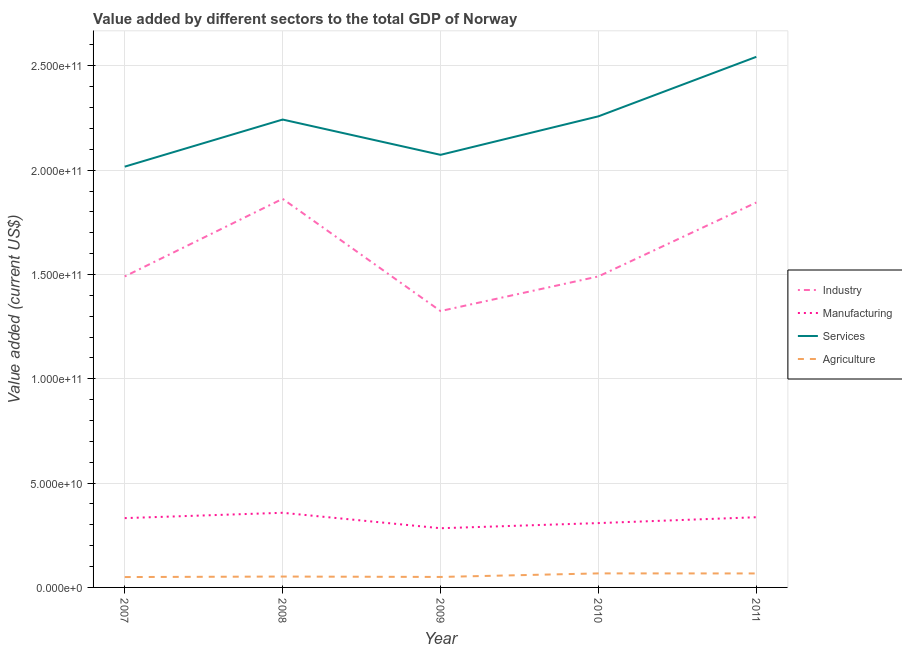How many different coloured lines are there?
Provide a short and direct response. 4. Is the number of lines equal to the number of legend labels?
Provide a succinct answer. Yes. What is the value added by industrial sector in 2010?
Keep it short and to the point. 1.49e+11. Across all years, what is the maximum value added by manufacturing sector?
Your response must be concise. 3.58e+1. Across all years, what is the minimum value added by services sector?
Your response must be concise. 2.02e+11. What is the total value added by services sector in the graph?
Provide a succinct answer. 1.11e+12. What is the difference between the value added by manufacturing sector in 2008 and that in 2011?
Give a very brief answer. 2.13e+09. What is the difference between the value added by industrial sector in 2009 and the value added by agricultural sector in 2008?
Ensure brevity in your answer.  1.27e+11. What is the average value added by agricultural sector per year?
Offer a terse response. 5.73e+09. In the year 2010, what is the difference between the value added by services sector and value added by agricultural sector?
Give a very brief answer. 2.19e+11. What is the ratio of the value added by services sector in 2007 to that in 2009?
Make the answer very short. 0.97. What is the difference between the highest and the second highest value added by agricultural sector?
Your response must be concise. 2.52e+07. What is the difference between the highest and the lowest value added by manufacturing sector?
Offer a terse response. 7.41e+09. In how many years, is the value added by manufacturing sector greater than the average value added by manufacturing sector taken over all years?
Offer a terse response. 3. Is the value added by manufacturing sector strictly less than the value added by agricultural sector over the years?
Offer a terse response. No. How many lines are there?
Give a very brief answer. 4. Does the graph contain grids?
Ensure brevity in your answer.  Yes. How are the legend labels stacked?
Provide a short and direct response. Vertical. What is the title of the graph?
Keep it short and to the point. Value added by different sectors to the total GDP of Norway. Does "Korea" appear as one of the legend labels in the graph?
Your answer should be compact. No. What is the label or title of the X-axis?
Make the answer very short. Year. What is the label or title of the Y-axis?
Offer a terse response. Value added (current US$). What is the Value added (current US$) of Industry in 2007?
Ensure brevity in your answer.  1.49e+11. What is the Value added (current US$) in Manufacturing in 2007?
Your answer should be compact. 3.32e+1. What is the Value added (current US$) in Services in 2007?
Ensure brevity in your answer.  2.02e+11. What is the Value added (current US$) in Agriculture in 2007?
Offer a very short reply. 4.97e+09. What is the Value added (current US$) of Industry in 2008?
Your response must be concise. 1.86e+11. What is the Value added (current US$) in Manufacturing in 2008?
Provide a succinct answer. 3.58e+1. What is the Value added (current US$) in Services in 2008?
Provide a short and direct response. 2.24e+11. What is the Value added (current US$) of Agriculture in 2008?
Give a very brief answer. 5.21e+09. What is the Value added (current US$) of Industry in 2009?
Ensure brevity in your answer.  1.32e+11. What is the Value added (current US$) in Manufacturing in 2009?
Your response must be concise. 2.84e+1. What is the Value added (current US$) of Services in 2009?
Provide a succinct answer. 2.07e+11. What is the Value added (current US$) of Agriculture in 2009?
Keep it short and to the point. 5.02e+09. What is the Value added (current US$) of Industry in 2010?
Provide a short and direct response. 1.49e+11. What is the Value added (current US$) of Manufacturing in 2010?
Ensure brevity in your answer.  3.08e+1. What is the Value added (current US$) of Services in 2010?
Give a very brief answer. 2.26e+11. What is the Value added (current US$) of Agriculture in 2010?
Keep it short and to the point. 6.73e+09. What is the Value added (current US$) of Industry in 2011?
Provide a succinct answer. 1.84e+11. What is the Value added (current US$) in Manufacturing in 2011?
Provide a short and direct response. 3.36e+1. What is the Value added (current US$) in Services in 2011?
Ensure brevity in your answer.  2.54e+11. What is the Value added (current US$) of Agriculture in 2011?
Your answer should be compact. 6.70e+09. Across all years, what is the maximum Value added (current US$) in Industry?
Give a very brief answer. 1.86e+11. Across all years, what is the maximum Value added (current US$) of Manufacturing?
Your response must be concise. 3.58e+1. Across all years, what is the maximum Value added (current US$) of Services?
Your answer should be very brief. 2.54e+11. Across all years, what is the maximum Value added (current US$) in Agriculture?
Make the answer very short. 6.73e+09. Across all years, what is the minimum Value added (current US$) of Industry?
Provide a succinct answer. 1.32e+11. Across all years, what is the minimum Value added (current US$) in Manufacturing?
Your response must be concise. 2.84e+1. Across all years, what is the minimum Value added (current US$) of Services?
Ensure brevity in your answer.  2.02e+11. Across all years, what is the minimum Value added (current US$) in Agriculture?
Give a very brief answer. 4.97e+09. What is the total Value added (current US$) in Industry in the graph?
Provide a succinct answer. 8.01e+11. What is the total Value added (current US$) of Manufacturing in the graph?
Offer a very short reply. 1.62e+11. What is the total Value added (current US$) of Services in the graph?
Provide a short and direct response. 1.11e+12. What is the total Value added (current US$) of Agriculture in the graph?
Offer a very short reply. 2.86e+1. What is the difference between the Value added (current US$) in Industry in 2007 and that in 2008?
Offer a terse response. -3.72e+1. What is the difference between the Value added (current US$) of Manufacturing in 2007 and that in 2008?
Ensure brevity in your answer.  -2.56e+09. What is the difference between the Value added (current US$) of Services in 2007 and that in 2008?
Give a very brief answer. -2.26e+1. What is the difference between the Value added (current US$) in Agriculture in 2007 and that in 2008?
Provide a succinct answer. -2.43e+08. What is the difference between the Value added (current US$) in Industry in 2007 and that in 2009?
Keep it short and to the point. 1.66e+1. What is the difference between the Value added (current US$) in Manufacturing in 2007 and that in 2009?
Your response must be concise. 4.85e+09. What is the difference between the Value added (current US$) in Services in 2007 and that in 2009?
Ensure brevity in your answer.  -5.67e+09. What is the difference between the Value added (current US$) in Agriculture in 2007 and that in 2009?
Make the answer very short. -5.06e+07. What is the difference between the Value added (current US$) in Industry in 2007 and that in 2010?
Your answer should be very brief. -1.07e+07. What is the difference between the Value added (current US$) of Manufacturing in 2007 and that in 2010?
Provide a succinct answer. 2.39e+09. What is the difference between the Value added (current US$) of Services in 2007 and that in 2010?
Your answer should be very brief. -2.41e+1. What is the difference between the Value added (current US$) of Agriculture in 2007 and that in 2010?
Provide a short and direct response. -1.75e+09. What is the difference between the Value added (current US$) in Industry in 2007 and that in 2011?
Provide a short and direct response. -3.54e+1. What is the difference between the Value added (current US$) in Manufacturing in 2007 and that in 2011?
Provide a succinct answer. -4.24e+08. What is the difference between the Value added (current US$) of Services in 2007 and that in 2011?
Keep it short and to the point. -5.26e+1. What is the difference between the Value added (current US$) in Agriculture in 2007 and that in 2011?
Offer a terse response. -1.73e+09. What is the difference between the Value added (current US$) of Industry in 2008 and that in 2009?
Make the answer very short. 5.38e+1. What is the difference between the Value added (current US$) of Manufacturing in 2008 and that in 2009?
Ensure brevity in your answer.  7.41e+09. What is the difference between the Value added (current US$) in Services in 2008 and that in 2009?
Ensure brevity in your answer.  1.69e+1. What is the difference between the Value added (current US$) of Agriculture in 2008 and that in 2009?
Your response must be concise. 1.92e+08. What is the difference between the Value added (current US$) of Industry in 2008 and that in 2010?
Make the answer very short. 3.72e+1. What is the difference between the Value added (current US$) in Manufacturing in 2008 and that in 2010?
Provide a short and direct response. 4.94e+09. What is the difference between the Value added (current US$) of Services in 2008 and that in 2010?
Give a very brief answer. -1.54e+09. What is the difference between the Value added (current US$) of Agriculture in 2008 and that in 2010?
Ensure brevity in your answer.  -1.51e+09. What is the difference between the Value added (current US$) in Industry in 2008 and that in 2011?
Keep it short and to the point. 1.77e+09. What is the difference between the Value added (current US$) of Manufacturing in 2008 and that in 2011?
Provide a short and direct response. 2.13e+09. What is the difference between the Value added (current US$) in Services in 2008 and that in 2011?
Your answer should be very brief. -3.01e+1. What is the difference between the Value added (current US$) in Agriculture in 2008 and that in 2011?
Your answer should be compact. -1.49e+09. What is the difference between the Value added (current US$) in Industry in 2009 and that in 2010?
Ensure brevity in your answer.  -1.66e+1. What is the difference between the Value added (current US$) in Manufacturing in 2009 and that in 2010?
Offer a terse response. -2.46e+09. What is the difference between the Value added (current US$) of Services in 2009 and that in 2010?
Make the answer very short. -1.85e+1. What is the difference between the Value added (current US$) of Agriculture in 2009 and that in 2010?
Offer a very short reply. -1.70e+09. What is the difference between the Value added (current US$) of Industry in 2009 and that in 2011?
Provide a succinct answer. -5.20e+1. What is the difference between the Value added (current US$) of Manufacturing in 2009 and that in 2011?
Offer a very short reply. -5.28e+09. What is the difference between the Value added (current US$) of Services in 2009 and that in 2011?
Provide a short and direct response. -4.70e+1. What is the difference between the Value added (current US$) in Agriculture in 2009 and that in 2011?
Keep it short and to the point. -1.68e+09. What is the difference between the Value added (current US$) in Industry in 2010 and that in 2011?
Offer a terse response. -3.54e+1. What is the difference between the Value added (current US$) in Manufacturing in 2010 and that in 2011?
Give a very brief answer. -2.81e+09. What is the difference between the Value added (current US$) in Services in 2010 and that in 2011?
Your response must be concise. -2.85e+1. What is the difference between the Value added (current US$) in Agriculture in 2010 and that in 2011?
Keep it short and to the point. 2.52e+07. What is the difference between the Value added (current US$) of Industry in 2007 and the Value added (current US$) of Manufacturing in 2008?
Provide a succinct answer. 1.13e+11. What is the difference between the Value added (current US$) of Industry in 2007 and the Value added (current US$) of Services in 2008?
Keep it short and to the point. -7.52e+1. What is the difference between the Value added (current US$) in Industry in 2007 and the Value added (current US$) in Agriculture in 2008?
Offer a terse response. 1.44e+11. What is the difference between the Value added (current US$) of Manufacturing in 2007 and the Value added (current US$) of Services in 2008?
Provide a succinct answer. -1.91e+11. What is the difference between the Value added (current US$) of Manufacturing in 2007 and the Value added (current US$) of Agriculture in 2008?
Your response must be concise. 2.80e+1. What is the difference between the Value added (current US$) in Services in 2007 and the Value added (current US$) in Agriculture in 2008?
Ensure brevity in your answer.  1.96e+11. What is the difference between the Value added (current US$) of Industry in 2007 and the Value added (current US$) of Manufacturing in 2009?
Offer a terse response. 1.21e+11. What is the difference between the Value added (current US$) of Industry in 2007 and the Value added (current US$) of Services in 2009?
Offer a very short reply. -5.83e+1. What is the difference between the Value added (current US$) of Industry in 2007 and the Value added (current US$) of Agriculture in 2009?
Your answer should be very brief. 1.44e+11. What is the difference between the Value added (current US$) of Manufacturing in 2007 and the Value added (current US$) of Services in 2009?
Make the answer very short. -1.74e+11. What is the difference between the Value added (current US$) in Manufacturing in 2007 and the Value added (current US$) in Agriculture in 2009?
Provide a succinct answer. 2.82e+1. What is the difference between the Value added (current US$) in Services in 2007 and the Value added (current US$) in Agriculture in 2009?
Keep it short and to the point. 1.97e+11. What is the difference between the Value added (current US$) of Industry in 2007 and the Value added (current US$) of Manufacturing in 2010?
Keep it short and to the point. 1.18e+11. What is the difference between the Value added (current US$) in Industry in 2007 and the Value added (current US$) in Services in 2010?
Offer a terse response. -7.67e+1. What is the difference between the Value added (current US$) in Industry in 2007 and the Value added (current US$) in Agriculture in 2010?
Give a very brief answer. 1.42e+11. What is the difference between the Value added (current US$) of Manufacturing in 2007 and the Value added (current US$) of Services in 2010?
Your answer should be very brief. -1.93e+11. What is the difference between the Value added (current US$) in Manufacturing in 2007 and the Value added (current US$) in Agriculture in 2010?
Offer a very short reply. 2.65e+1. What is the difference between the Value added (current US$) in Services in 2007 and the Value added (current US$) in Agriculture in 2010?
Provide a short and direct response. 1.95e+11. What is the difference between the Value added (current US$) of Industry in 2007 and the Value added (current US$) of Manufacturing in 2011?
Your answer should be very brief. 1.15e+11. What is the difference between the Value added (current US$) in Industry in 2007 and the Value added (current US$) in Services in 2011?
Ensure brevity in your answer.  -1.05e+11. What is the difference between the Value added (current US$) of Industry in 2007 and the Value added (current US$) of Agriculture in 2011?
Your answer should be compact. 1.42e+11. What is the difference between the Value added (current US$) of Manufacturing in 2007 and the Value added (current US$) of Services in 2011?
Make the answer very short. -2.21e+11. What is the difference between the Value added (current US$) in Manufacturing in 2007 and the Value added (current US$) in Agriculture in 2011?
Offer a very short reply. 2.65e+1. What is the difference between the Value added (current US$) of Services in 2007 and the Value added (current US$) of Agriculture in 2011?
Make the answer very short. 1.95e+11. What is the difference between the Value added (current US$) in Industry in 2008 and the Value added (current US$) in Manufacturing in 2009?
Make the answer very short. 1.58e+11. What is the difference between the Value added (current US$) in Industry in 2008 and the Value added (current US$) in Services in 2009?
Your answer should be very brief. -2.11e+1. What is the difference between the Value added (current US$) in Industry in 2008 and the Value added (current US$) in Agriculture in 2009?
Your answer should be compact. 1.81e+11. What is the difference between the Value added (current US$) of Manufacturing in 2008 and the Value added (current US$) of Services in 2009?
Your answer should be compact. -1.72e+11. What is the difference between the Value added (current US$) of Manufacturing in 2008 and the Value added (current US$) of Agriculture in 2009?
Your answer should be very brief. 3.08e+1. What is the difference between the Value added (current US$) of Services in 2008 and the Value added (current US$) of Agriculture in 2009?
Make the answer very short. 2.19e+11. What is the difference between the Value added (current US$) of Industry in 2008 and the Value added (current US$) of Manufacturing in 2010?
Keep it short and to the point. 1.55e+11. What is the difference between the Value added (current US$) of Industry in 2008 and the Value added (current US$) of Services in 2010?
Keep it short and to the point. -3.95e+1. What is the difference between the Value added (current US$) of Industry in 2008 and the Value added (current US$) of Agriculture in 2010?
Offer a very short reply. 1.80e+11. What is the difference between the Value added (current US$) in Manufacturing in 2008 and the Value added (current US$) in Services in 2010?
Keep it short and to the point. -1.90e+11. What is the difference between the Value added (current US$) in Manufacturing in 2008 and the Value added (current US$) in Agriculture in 2010?
Offer a terse response. 2.91e+1. What is the difference between the Value added (current US$) of Services in 2008 and the Value added (current US$) of Agriculture in 2010?
Give a very brief answer. 2.18e+11. What is the difference between the Value added (current US$) in Industry in 2008 and the Value added (current US$) in Manufacturing in 2011?
Offer a very short reply. 1.53e+11. What is the difference between the Value added (current US$) in Industry in 2008 and the Value added (current US$) in Services in 2011?
Make the answer very short. -6.81e+1. What is the difference between the Value added (current US$) in Industry in 2008 and the Value added (current US$) in Agriculture in 2011?
Offer a very short reply. 1.80e+11. What is the difference between the Value added (current US$) in Manufacturing in 2008 and the Value added (current US$) in Services in 2011?
Your response must be concise. -2.19e+11. What is the difference between the Value added (current US$) in Manufacturing in 2008 and the Value added (current US$) in Agriculture in 2011?
Your answer should be compact. 2.91e+1. What is the difference between the Value added (current US$) in Services in 2008 and the Value added (current US$) in Agriculture in 2011?
Offer a terse response. 2.18e+11. What is the difference between the Value added (current US$) in Industry in 2009 and the Value added (current US$) in Manufacturing in 2010?
Keep it short and to the point. 1.02e+11. What is the difference between the Value added (current US$) of Industry in 2009 and the Value added (current US$) of Services in 2010?
Your answer should be compact. -9.33e+1. What is the difference between the Value added (current US$) in Industry in 2009 and the Value added (current US$) in Agriculture in 2010?
Your answer should be very brief. 1.26e+11. What is the difference between the Value added (current US$) in Manufacturing in 2009 and the Value added (current US$) in Services in 2010?
Offer a terse response. -1.97e+11. What is the difference between the Value added (current US$) in Manufacturing in 2009 and the Value added (current US$) in Agriculture in 2010?
Ensure brevity in your answer.  2.16e+1. What is the difference between the Value added (current US$) of Services in 2009 and the Value added (current US$) of Agriculture in 2010?
Provide a succinct answer. 2.01e+11. What is the difference between the Value added (current US$) of Industry in 2009 and the Value added (current US$) of Manufacturing in 2011?
Provide a short and direct response. 9.88e+1. What is the difference between the Value added (current US$) of Industry in 2009 and the Value added (current US$) of Services in 2011?
Make the answer very short. -1.22e+11. What is the difference between the Value added (current US$) in Industry in 2009 and the Value added (current US$) in Agriculture in 2011?
Your answer should be very brief. 1.26e+11. What is the difference between the Value added (current US$) of Manufacturing in 2009 and the Value added (current US$) of Services in 2011?
Your answer should be compact. -2.26e+11. What is the difference between the Value added (current US$) in Manufacturing in 2009 and the Value added (current US$) in Agriculture in 2011?
Give a very brief answer. 2.17e+1. What is the difference between the Value added (current US$) in Services in 2009 and the Value added (current US$) in Agriculture in 2011?
Ensure brevity in your answer.  2.01e+11. What is the difference between the Value added (current US$) in Industry in 2010 and the Value added (current US$) in Manufacturing in 2011?
Ensure brevity in your answer.  1.15e+11. What is the difference between the Value added (current US$) of Industry in 2010 and the Value added (current US$) of Services in 2011?
Your response must be concise. -1.05e+11. What is the difference between the Value added (current US$) in Industry in 2010 and the Value added (current US$) in Agriculture in 2011?
Provide a succinct answer. 1.42e+11. What is the difference between the Value added (current US$) of Manufacturing in 2010 and the Value added (current US$) of Services in 2011?
Provide a short and direct response. -2.23e+11. What is the difference between the Value added (current US$) of Manufacturing in 2010 and the Value added (current US$) of Agriculture in 2011?
Ensure brevity in your answer.  2.41e+1. What is the difference between the Value added (current US$) of Services in 2010 and the Value added (current US$) of Agriculture in 2011?
Give a very brief answer. 2.19e+11. What is the average Value added (current US$) in Industry per year?
Give a very brief answer. 1.60e+11. What is the average Value added (current US$) of Manufacturing per year?
Give a very brief answer. 3.24e+1. What is the average Value added (current US$) in Services per year?
Your answer should be compact. 2.23e+11. What is the average Value added (current US$) of Agriculture per year?
Your response must be concise. 5.73e+09. In the year 2007, what is the difference between the Value added (current US$) of Industry and Value added (current US$) of Manufacturing?
Ensure brevity in your answer.  1.16e+11. In the year 2007, what is the difference between the Value added (current US$) of Industry and Value added (current US$) of Services?
Give a very brief answer. -5.26e+1. In the year 2007, what is the difference between the Value added (current US$) in Industry and Value added (current US$) in Agriculture?
Provide a short and direct response. 1.44e+11. In the year 2007, what is the difference between the Value added (current US$) in Manufacturing and Value added (current US$) in Services?
Provide a succinct answer. -1.68e+11. In the year 2007, what is the difference between the Value added (current US$) of Manufacturing and Value added (current US$) of Agriculture?
Your answer should be compact. 2.83e+1. In the year 2007, what is the difference between the Value added (current US$) in Services and Value added (current US$) in Agriculture?
Give a very brief answer. 1.97e+11. In the year 2008, what is the difference between the Value added (current US$) in Industry and Value added (current US$) in Manufacturing?
Make the answer very short. 1.50e+11. In the year 2008, what is the difference between the Value added (current US$) of Industry and Value added (current US$) of Services?
Offer a very short reply. -3.80e+1. In the year 2008, what is the difference between the Value added (current US$) of Industry and Value added (current US$) of Agriculture?
Give a very brief answer. 1.81e+11. In the year 2008, what is the difference between the Value added (current US$) of Manufacturing and Value added (current US$) of Services?
Your answer should be compact. -1.88e+11. In the year 2008, what is the difference between the Value added (current US$) of Manufacturing and Value added (current US$) of Agriculture?
Keep it short and to the point. 3.06e+1. In the year 2008, what is the difference between the Value added (current US$) of Services and Value added (current US$) of Agriculture?
Your answer should be very brief. 2.19e+11. In the year 2009, what is the difference between the Value added (current US$) in Industry and Value added (current US$) in Manufacturing?
Provide a short and direct response. 1.04e+11. In the year 2009, what is the difference between the Value added (current US$) in Industry and Value added (current US$) in Services?
Your answer should be very brief. -7.49e+1. In the year 2009, what is the difference between the Value added (current US$) in Industry and Value added (current US$) in Agriculture?
Ensure brevity in your answer.  1.27e+11. In the year 2009, what is the difference between the Value added (current US$) in Manufacturing and Value added (current US$) in Services?
Your response must be concise. -1.79e+11. In the year 2009, what is the difference between the Value added (current US$) in Manufacturing and Value added (current US$) in Agriculture?
Ensure brevity in your answer.  2.34e+1. In the year 2009, what is the difference between the Value added (current US$) of Services and Value added (current US$) of Agriculture?
Make the answer very short. 2.02e+11. In the year 2010, what is the difference between the Value added (current US$) of Industry and Value added (current US$) of Manufacturing?
Keep it short and to the point. 1.18e+11. In the year 2010, what is the difference between the Value added (current US$) of Industry and Value added (current US$) of Services?
Provide a succinct answer. -7.67e+1. In the year 2010, what is the difference between the Value added (current US$) of Industry and Value added (current US$) of Agriculture?
Make the answer very short. 1.42e+11. In the year 2010, what is the difference between the Value added (current US$) of Manufacturing and Value added (current US$) of Services?
Provide a succinct answer. -1.95e+11. In the year 2010, what is the difference between the Value added (current US$) of Manufacturing and Value added (current US$) of Agriculture?
Ensure brevity in your answer.  2.41e+1. In the year 2010, what is the difference between the Value added (current US$) of Services and Value added (current US$) of Agriculture?
Offer a very short reply. 2.19e+11. In the year 2011, what is the difference between the Value added (current US$) in Industry and Value added (current US$) in Manufacturing?
Offer a very short reply. 1.51e+11. In the year 2011, what is the difference between the Value added (current US$) in Industry and Value added (current US$) in Services?
Give a very brief answer. -6.98e+1. In the year 2011, what is the difference between the Value added (current US$) of Industry and Value added (current US$) of Agriculture?
Provide a succinct answer. 1.78e+11. In the year 2011, what is the difference between the Value added (current US$) of Manufacturing and Value added (current US$) of Services?
Make the answer very short. -2.21e+11. In the year 2011, what is the difference between the Value added (current US$) in Manufacturing and Value added (current US$) in Agriculture?
Provide a succinct answer. 2.69e+1. In the year 2011, what is the difference between the Value added (current US$) of Services and Value added (current US$) of Agriculture?
Provide a short and direct response. 2.48e+11. What is the ratio of the Value added (current US$) of Industry in 2007 to that in 2008?
Make the answer very short. 0.8. What is the ratio of the Value added (current US$) in Manufacturing in 2007 to that in 2008?
Give a very brief answer. 0.93. What is the ratio of the Value added (current US$) in Services in 2007 to that in 2008?
Offer a terse response. 0.9. What is the ratio of the Value added (current US$) in Agriculture in 2007 to that in 2008?
Provide a short and direct response. 0.95. What is the ratio of the Value added (current US$) of Industry in 2007 to that in 2009?
Offer a terse response. 1.13. What is the ratio of the Value added (current US$) in Manufacturing in 2007 to that in 2009?
Offer a terse response. 1.17. What is the ratio of the Value added (current US$) of Services in 2007 to that in 2009?
Your response must be concise. 0.97. What is the ratio of the Value added (current US$) in Industry in 2007 to that in 2010?
Your answer should be very brief. 1. What is the ratio of the Value added (current US$) of Manufacturing in 2007 to that in 2010?
Ensure brevity in your answer.  1.08. What is the ratio of the Value added (current US$) in Services in 2007 to that in 2010?
Your answer should be compact. 0.89. What is the ratio of the Value added (current US$) of Agriculture in 2007 to that in 2010?
Provide a succinct answer. 0.74. What is the ratio of the Value added (current US$) of Industry in 2007 to that in 2011?
Give a very brief answer. 0.81. What is the ratio of the Value added (current US$) in Manufacturing in 2007 to that in 2011?
Your answer should be compact. 0.99. What is the ratio of the Value added (current US$) in Services in 2007 to that in 2011?
Provide a short and direct response. 0.79. What is the ratio of the Value added (current US$) of Agriculture in 2007 to that in 2011?
Offer a very short reply. 0.74. What is the ratio of the Value added (current US$) in Industry in 2008 to that in 2009?
Keep it short and to the point. 1.41. What is the ratio of the Value added (current US$) in Manufacturing in 2008 to that in 2009?
Offer a very short reply. 1.26. What is the ratio of the Value added (current US$) in Services in 2008 to that in 2009?
Provide a short and direct response. 1.08. What is the ratio of the Value added (current US$) in Agriculture in 2008 to that in 2009?
Ensure brevity in your answer.  1.04. What is the ratio of the Value added (current US$) of Industry in 2008 to that in 2010?
Offer a terse response. 1.25. What is the ratio of the Value added (current US$) in Manufacturing in 2008 to that in 2010?
Ensure brevity in your answer.  1.16. What is the ratio of the Value added (current US$) in Services in 2008 to that in 2010?
Make the answer very short. 0.99. What is the ratio of the Value added (current US$) in Agriculture in 2008 to that in 2010?
Your response must be concise. 0.78. What is the ratio of the Value added (current US$) of Industry in 2008 to that in 2011?
Provide a succinct answer. 1.01. What is the ratio of the Value added (current US$) of Manufacturing in 2008 to that in 2011?
Keep it short and to the point. 1.06. What is the ratio of the Value added (current US$) of Services in 2008 to that in 2011?
Give a very brief answer. 0.88. What is the ratio of the Value added (current US$) of Agriculture in 2008 to that in 2011?
Keep it short and to the point. 0.78. What is the ratio of the Value added (current US$) in Industry in 2009 to that in 2010?
Provide a short and direct response. 0.89. What is the ratio of the Value added (current US$) in Manufacturing in 2009 to that in 2010?
Ensure brevity in your answer.  0.92. What is the ratio of the Value added (current US$) in Services in 2009 to that in 2010?
Make the answer very short. 0.92. What is the ratio of the Value added (current US$) of Agriculture in 2009 to that in 2010?
Provide a succinct answer. 0.75. What is the ratio of the Value added (current US$) in Industry in 2009 to that in 2011?
Ensure brevity in your answer.  0.72. What is the ratio of the Value added (current US$) of Manufacturing in 2009 to that in 2011?
Offer a terse response. 0.84. What is the ratio of the Value added (current US$) in Services in 2009 to that in 2011?
Your answer should be compact. 0.82. What is the ratio of the Value added (current US$) in Agriculture in 2009 to that in 2011?
Your answer should be very brief. 0.75. What is the ratio of the Value added (current US$) of Industry in 2010 to that in 2011?
Offer a terse response. 0.81. What is the ratio of the Value added (current US$) of Manufacturing in 2010 to that in 2011?
Offer a terse response. 0.92. What is the ratio of the Value added (current US$) in Services in 2010 to that in 2011?
Keep it short and to the point. 0.89. What is the difference between the highest and the second highest Value added (current US$) in Industry?
Your response must be concise. 1.77e+09. What is the difference between the highest and the second highest Value added (current US$) in Manufacturing?
Provide a short and direct response. 2.13e+09. What is the difference between the highest and the second highest Value added (current US$) in Services?
Your answer should be very brief. 2.85e+1. What is the difference between the highest and the second highest Value added (current US$) in Agriculture?
Offer a very short reply. 2.52e+07. What is the difference between the highest and the lowest Value added (current US$) in Industry?
Offer a very short reply. 5.38e+1. What is the difference between the highest and the lowest Value added (current US$) in Manufacturing?
Offer a terse response. 7.41e+09. What is the difference between the highest and the lowest Value added (current US$) in Services?
Your response must be concise. 5.26e+1. What is the difference between the highest and the lowest Value added (current US$) in Agriculture?
Make the answer very short. 1.75e+09. 